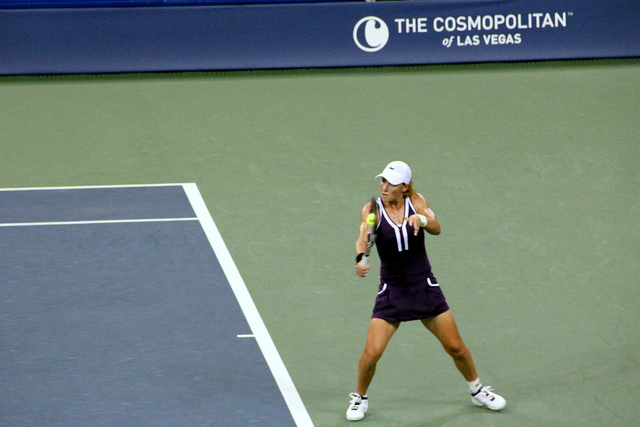<image>What brand of clothing is she wearing? I am unsure about the brand of clothing she is wearing. It could be 'Nike' or 'Adidas'. What brand of clothing is she wearing? I don't know what brand of clothing she is wearing. It could be Nike, Adidas, or another unknown brand. 